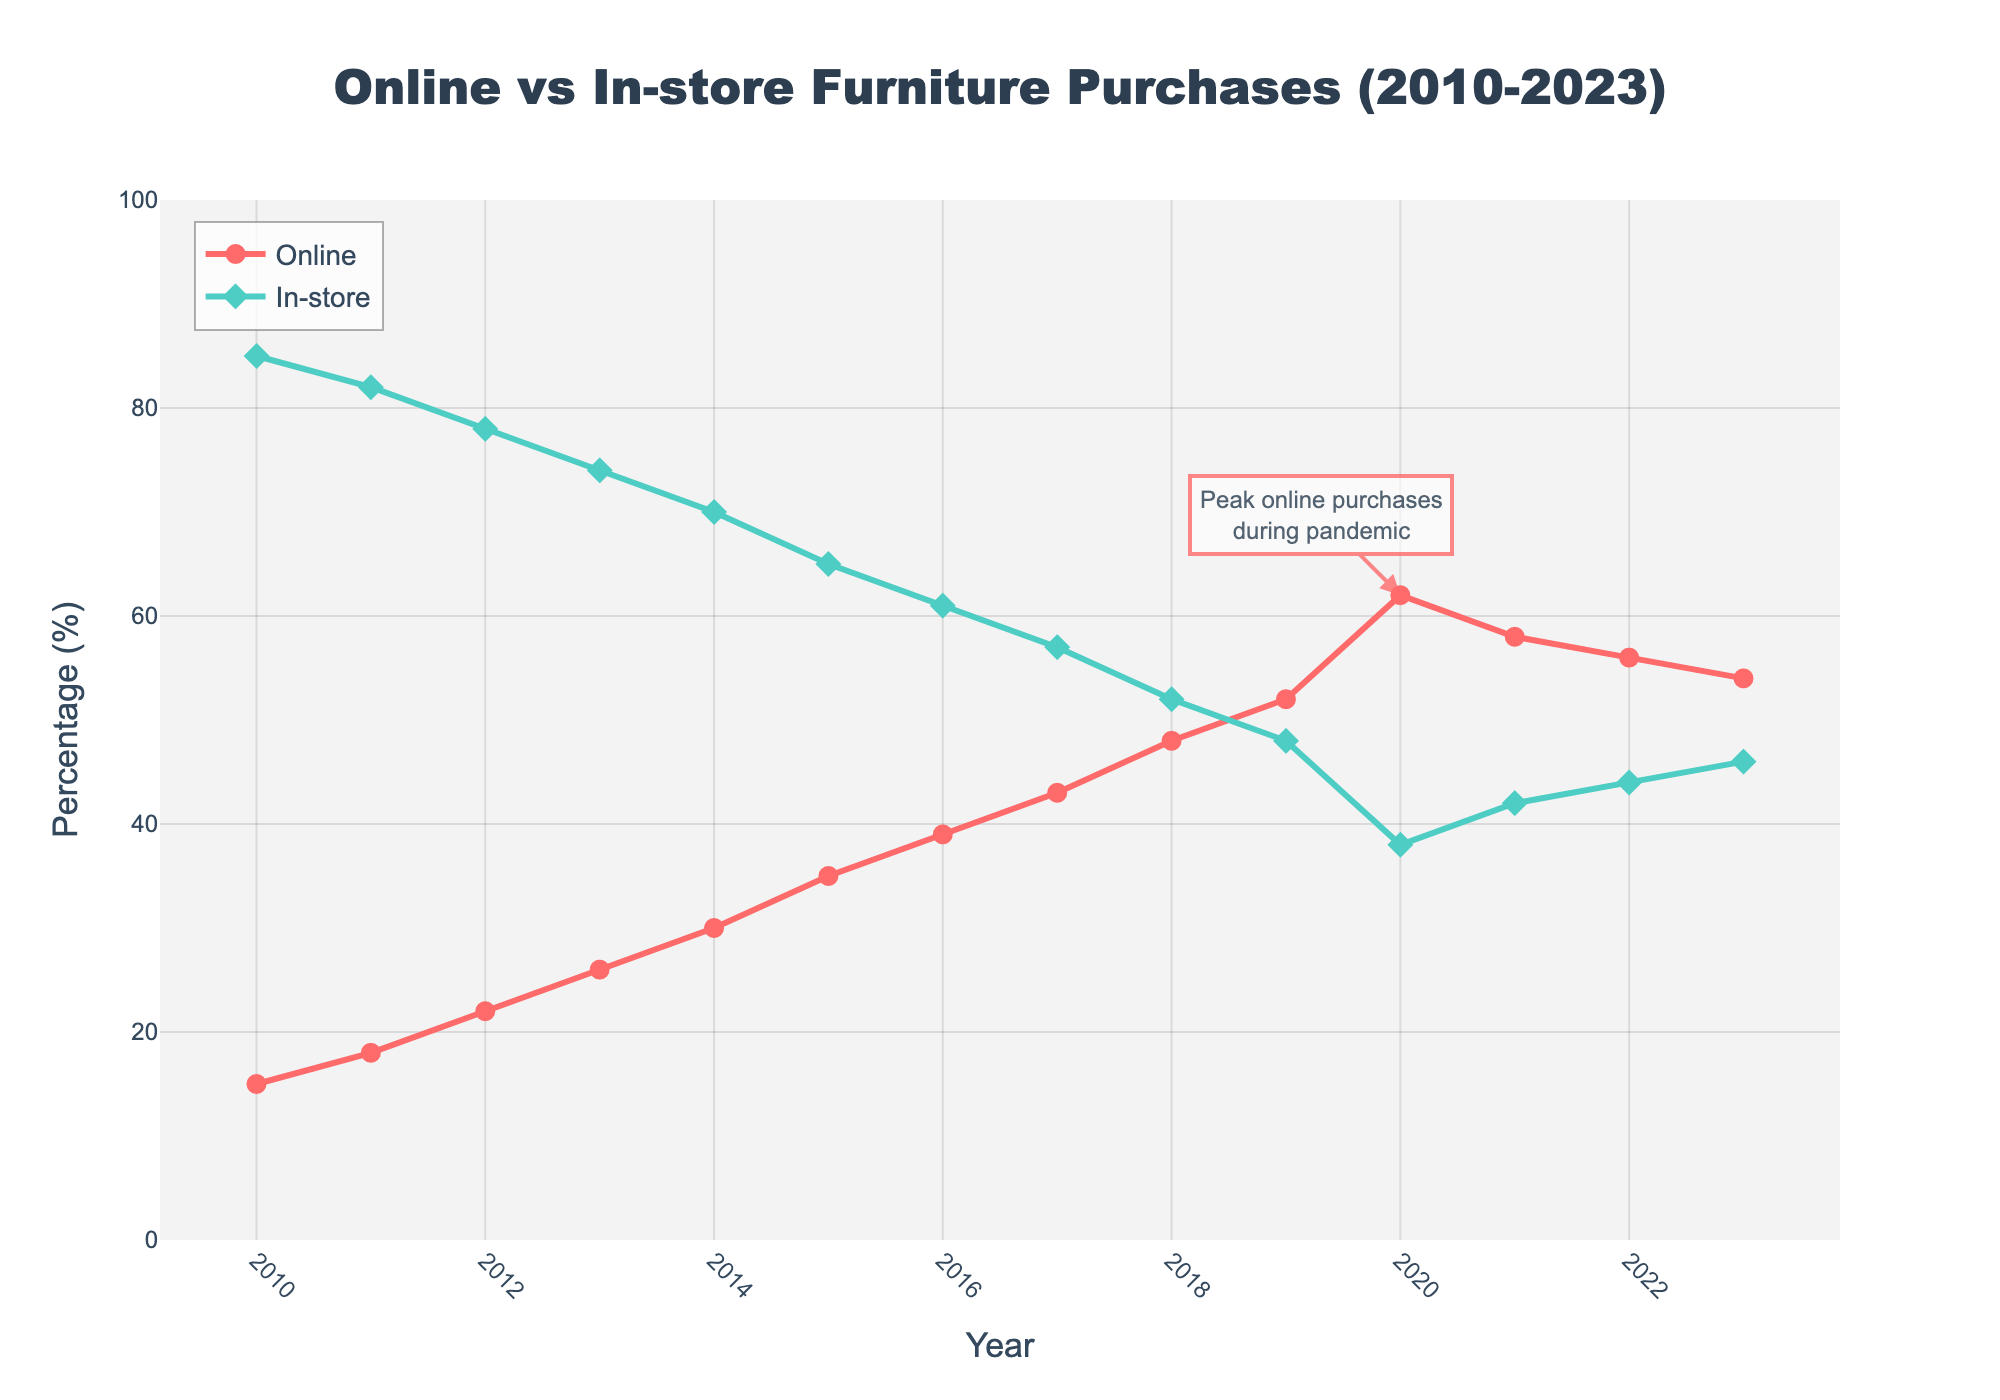what are the percentages for online and in-store purchases in 2023? Look at the values for 2023 on the respective lines.
Answer: 54% online, 46% in-store Has online or in-store purchasing generally increased over the years? Compare the overall trend from 2010 to 2023 for both online and in-store purchases. Online purchasing has increased while in-store has decreased.
Answer: Online increased, in-store decreased When did online purchases surpass in-store purchases? Look for the year when the online line crosses above the in-store line. This occurs in 2019 where online purchases (52%) are higher than in-store purchases (48%).
Answer: 2019 By how much did online purchases drop from 2020 to 2021? Find the difference in the percentage of online purchases between 2020 and 2021. In 2020, it's 62% and in 2021, it's 58%.
Answer: 4% What was the peak percentage for online purchases, and in which year did it occur? Identify the highest point on the online purchases line and note the corresponding year. The highest value is 62% in the year 2020.
Answer: 62% in 2020 In which year was the percentage of in-store purchases lowest, and what was that percentage? Identify the lowest point on the in-store purchases line and note the corresponding year and value. The lowest value is 38% in 2020.
Answer: 38% in 2020 How have online and in-store purchases changed from 2015 to 2018? Compare the values for online and in-store purchases from 2015 to 2018. Online purchases went from 35% to 48%, and in-store purchases went from 65% to 52%.
Answer: Online increased from 35% to 48%, in-store decreased from 65% to 52% Between 2014 and 2015, what was the rate of increase for online purchases? Calculate the percentage increase from 2014 to 2015: (35% - 30%)/30% * 100%.
Answer: 16.67% What trend is observed in the year 2023 as compared to the years following the peak in 2020? Compare the online purchase percentage in 2023 with those in 2021 and 2022, noting whether it's increasing or decreasing. There is a steady decrease from 2020 to 2023.
Answer: Decreasing trend 